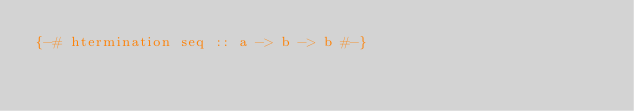<code> <loc_0><loc_0><loc_500><loc_500><_Haskell_>{-# htermination seq :: a -> b -> b #-}
</code> 